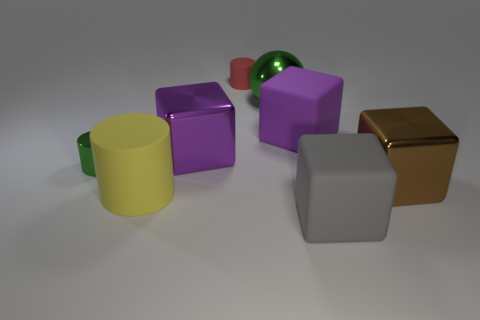Are there any other things that are the same material as the big brown block?
Keep it short and to the point. Yes. Are the brown thing that is on the right side of the small green cylinder and the tiny green object made of the same material?
Your answer should be very brief. Yes. Is the number of big yellow things that are left of the yellow object less than the number of yellow things?
Give a very brief answer. Yes. How many metal things are either small cylinders or large green spheres?
Make the answer very short. 2. Is the color of the big cylinder the same as the small rubber object?
Provide a succinct answer. No. Are there any other things that have the same color as the metallic cylinder?
Your answer should be very brief. Yes. There is a green thing that is right of the small green metallic thing; does it have the same shape as the small object that is in front of the large purple metal thing?
Your answer should be very brief. No. What number of objects are metallic cylinders or cubes behind the large brown thing?
Offer a very short reply. 3. What number of other things are there of the same size as the brown thing?
Keep it short and to the point. 5. Is the tiny cylinder on the right side of the yellow cylinder made of the same material as the tiny thing that is in front of the large purple matte object?
Give a very brief answer. No. 